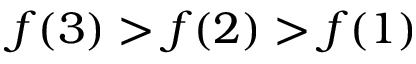Convert formula to latex. <formula><loc_0><loc_0><loc_500><loc_500>f ( 3 ) > f ( 2 ) > f ( 1 )</formula> 